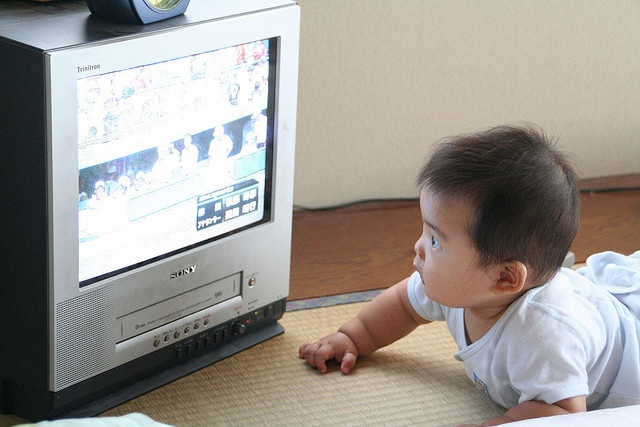Describe the objects in this image and their specific colors. I can see tv in black, white, darkgray, and gray tones, people in black, darkgray, lavender, and gray tones, and clock in black, darkgray, and gray tones in this image. 